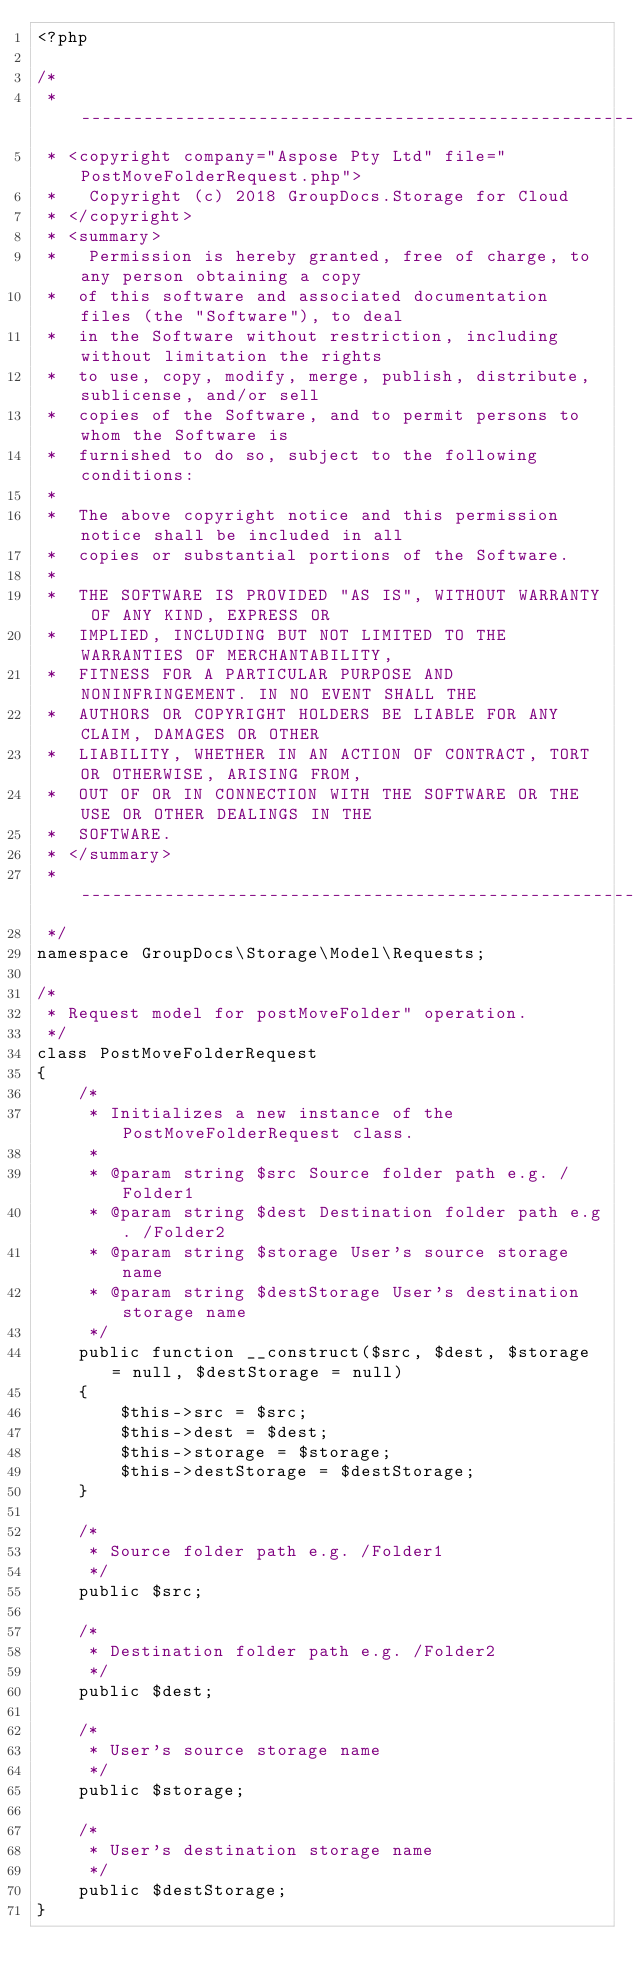Convert code to text. <code><loc_0><loc_0><loc_500><loc_500><_PHP_><?php

/*
 * --------------------------------------------------------------------------------------------------------------------
 * <copyright company="Aspose Pty Ltd" file="PostMoveFolderRequest.php">
 *   Copyright (c) 2018 GroupDocs.Storage for Cloud
 * </copyright>
 * <summary>
 *   Permission is hereby granted, free of charge, to any person obtaining a copy
 *  of this software and associated documentation files (the "Software"), to deal
 *  in the Software without restriction, including without limitation the rights
 *  to use, copy, modify, merge, publish, distribute, sublicense, and/or sell
 *  copies of the Software, and to permit persons to whom the Software is
 *  furnished to do so, subject to the following conditions:
 * 
 *  The above copyright notice and this permission notice shall be included in all
 *  copies or substantial portions of the Software.
 * 
 *  THE SOFTWARE IS PROVIDED "AS IS", WITHOUT WARRANTY OF ANY KIND, EXPRESS OR
 *  IMPLIED, INCLUDING BUT NOT LIMITED TO THE WARRANTIES OF MERCHANTABILITY,
 *  FITNESS FOR A PARTICULAR PURPOSE AND NONINFRINGEMENT. IN NO EVENT SHALL THE
 *  AUTHORS OR COPYRIGHT HOLDERS BE LIABLE FOR ANY CLAIM, DAMAGES OR OTHER
 *  LIABILITY, WHETHER IN AN ACTION OF CONTRACT, TORT OR OTHERWISE, ARISING FROM,
 *  OUT OF OR IN CONNECTION WITH THE SOFTWARE OR THE USE OR OTHER DEALINGS IN THE
 *  SOFTWARE.
 * </summary>
 * --------------------------------------------------------------------------------------------------------------------
 */
namespace GroupDocs\Storage\Model\Requests;

/*
 * Request model for postMoveFolder" operation.
 */
class PostMoveFolderRequest
{
    /*
     * Initializes a new instance of the PostMoveFolderRequest class.
     *  
     * @param string $src Source folder path e.g. /Folder1
     * @param string $dest Destination folder path e.g. /Folder2
     * @param string $storage User's source storage name
     * @param string $destStorage User's destination storage name
     */
    public function __construct($src, $dest, $storage = null, $destStorage = null)             
    {
        $this->src = $src;
        $this->dest = $dest;
        $this->storage = $storage;
        $this->destStorage = $destStorage;
    }

    /*
     * Source folder path e.g. /Folder1
     */
    public $src;

    /*
     * Destination folder path e.g. /Folder2
     */
    public $dest;

    /*
     * User's source storage name
     */
    public $storage;

    /*
     * User's destination storage name
     */
    public $destStorage;
}</code> 